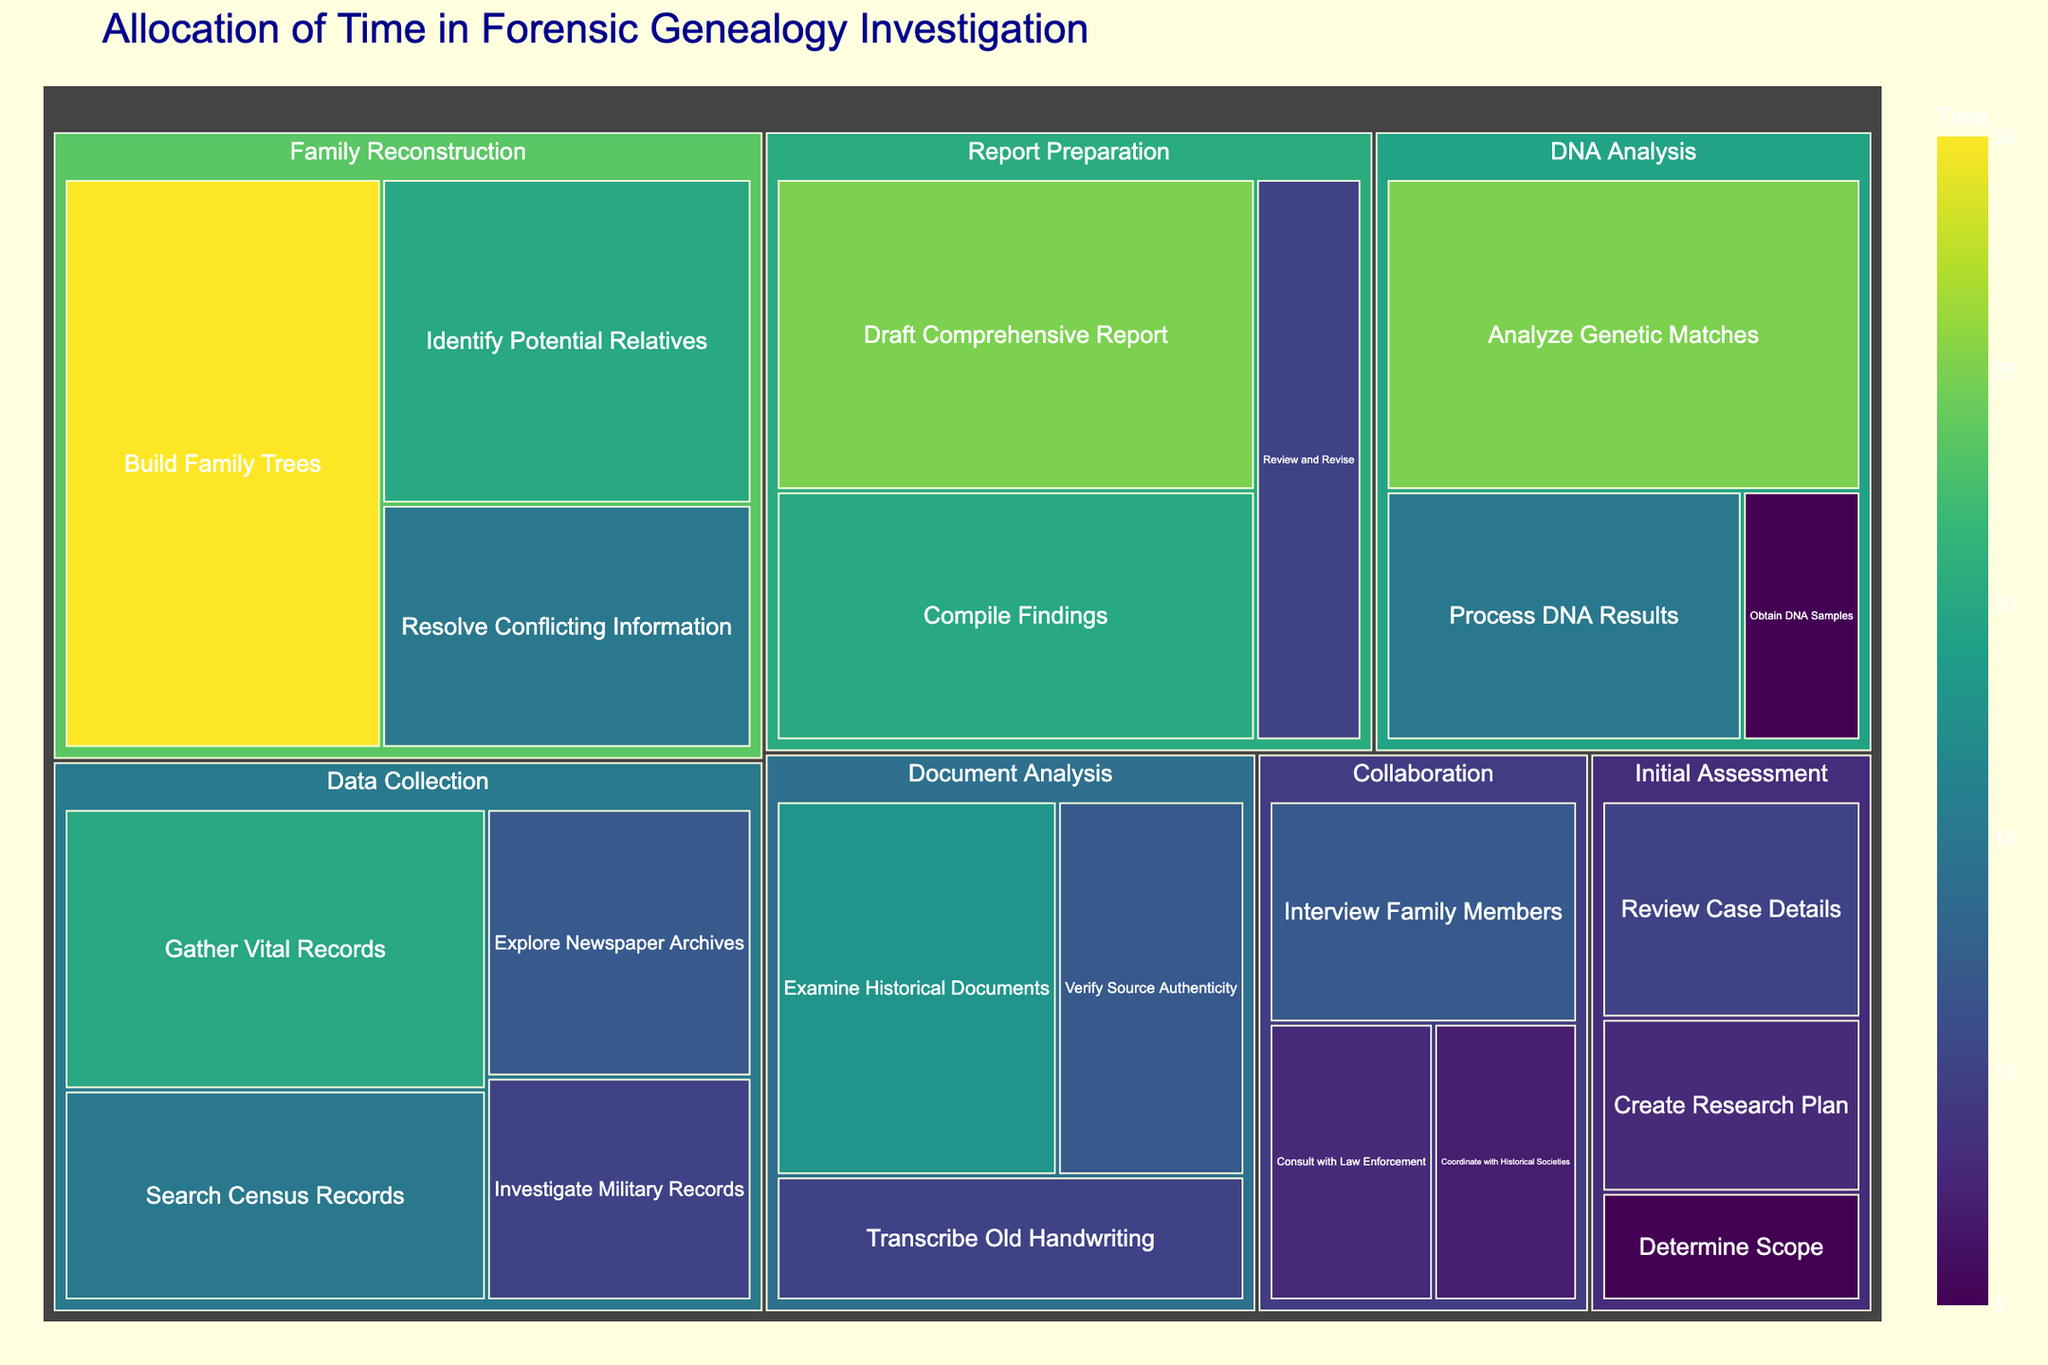what is the overall title of the plot? The title of the plot is typically located at the top of the figure and provides a descriptive summary of the visualized data. In this case, it clearly states the purpose of the visualization.
Answer: Allocation of Time in Forensic Genealogy Investigation Which phase has the longest time allocated to a single task? Determine which task has the highest value (time) within each phase, and then compare the highest values between phases. The "Family Reconstruction" phase with the task "Build Family Trees" has the highest time allocation of 30 hours.
Answer: Family Reconstruction How much total time is spent on the "DNA Analysis" phase? Add the time spent on each task within the "DNA Analysis" phase: Obtain DNA Samples (5) + Process DNA Results (15) + Analyze Genetic Matches (25). The sum equals 45 hours.
Answer: 45 hours Compare the time spent on "Gather Vital Records" and "Draft Comprehensive Report" tasks. Which takes longer? "Gather Vital Records" takes 20 hours, and "Draft Comprehensive Report" takes 25 hours. By comparing these values directly, we see that "Draft Comprehensive Report" takes longer.
Answer: Draft Comprehensive Report What is the average time spent on tasks in the "Document Analysis" phase? First, sum the time spent on tasks in the "Document Analysis" phase: Examine Historical Documents (18) + Verify Source Authenticity (12) + Transcribe Old Handwriting (10). The total time is 40 hours. Then, divide by the number of tasks (3). The average time is 40/3 hours.
Answer: 13.33 hours Which task in the "Collaboration" phase has the least time allocated, and how much time is that? Compare the times for tasks in the "Collaboration" phase: Consult with Law Enforcement (8), Interview Family Members (12), and Coordinate with Historical Societies (7). The least time is allocated to the "Coordinate with Historical Societies" task, which is 7 hours.
Answer: Coordinate with Historical Societies, 7 hours What is the total time spent on the phases "Data Collection" and "Report Preparation"? Sum the times for tasks within each phase: "Data Collection" phase is 20 (Gather Vital Records) + 15 (Search Census Records) + 12 (Explore Newspaper Archives) + 10 (Investigate Military Records) = 57 hours. "Report Preparation" phase is 20 (Compile Findings) + 25 (Draft Comprehensive Report) + 10 (Review and Revise) = 55 hours. The total time for both phases is 57 + 55 = 112 hours.
Answer: 112 hours Within the "Family Reconstruction" phase, how does the time spent on "Resolve Conflicting Information" compare to "Identify Potential Relatives"? The time spent on "Resolve Conflicting Information" is 15 hours, and "Identify Potential Relatives" is 20 hours. Comparing these values shows that "Identify Potential Relatives" has more time allocated.
Answer: Identify Potential Relatives What color represents the highest time allocation value, and which task does it correspond to? By checking the treemap color scale, the darkest shade (usually representing the highest value) is indicative of "Analyze Genetic Matches" under "DNA Analysis" which has 25 hours. The actual task with the highest allocation, "Build Family Trees" (30 hours), would correspond to this darker color.
Answer: Darkest color, Build Family Trees How much more time is spent on "Create Research Plan" compared to "Determine Scope" in the Initial Assessment phase? The time spent on "Create Research Plan" is 8 hours, and the time on "Determine Scope" is 5 hours. Subtract the smaller value from the larger value: 8 - 5. The difference is 3 hours.
Answer: 3 hours 